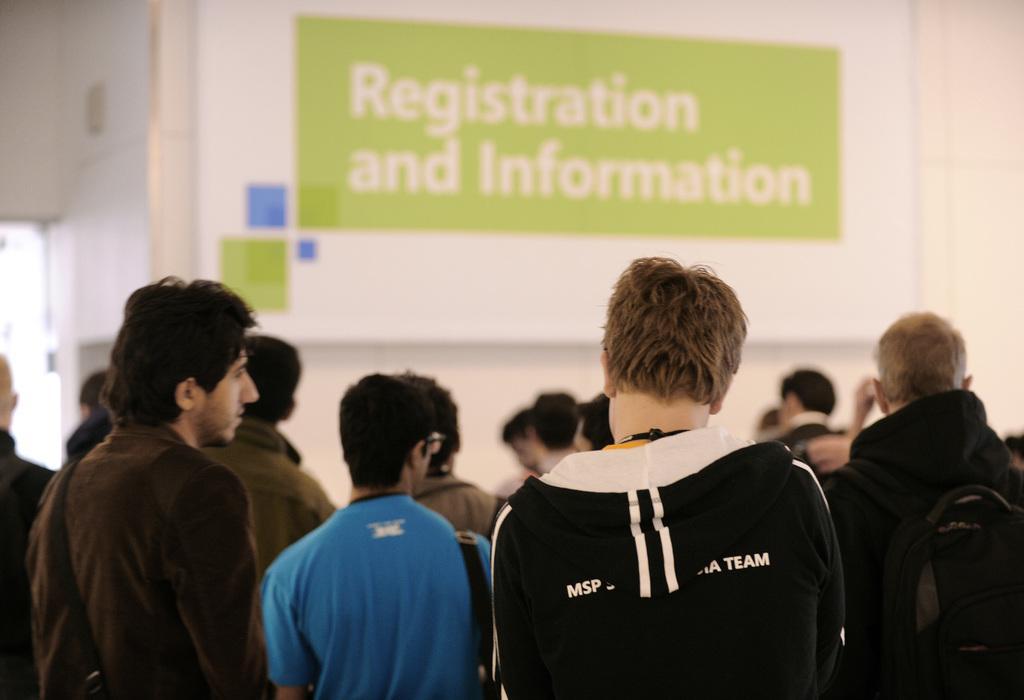Please provide a concise description of this image. In this image I can see the group of people with different color dresses. I can see these people are standing. In the background I can see the banner to the wall. 